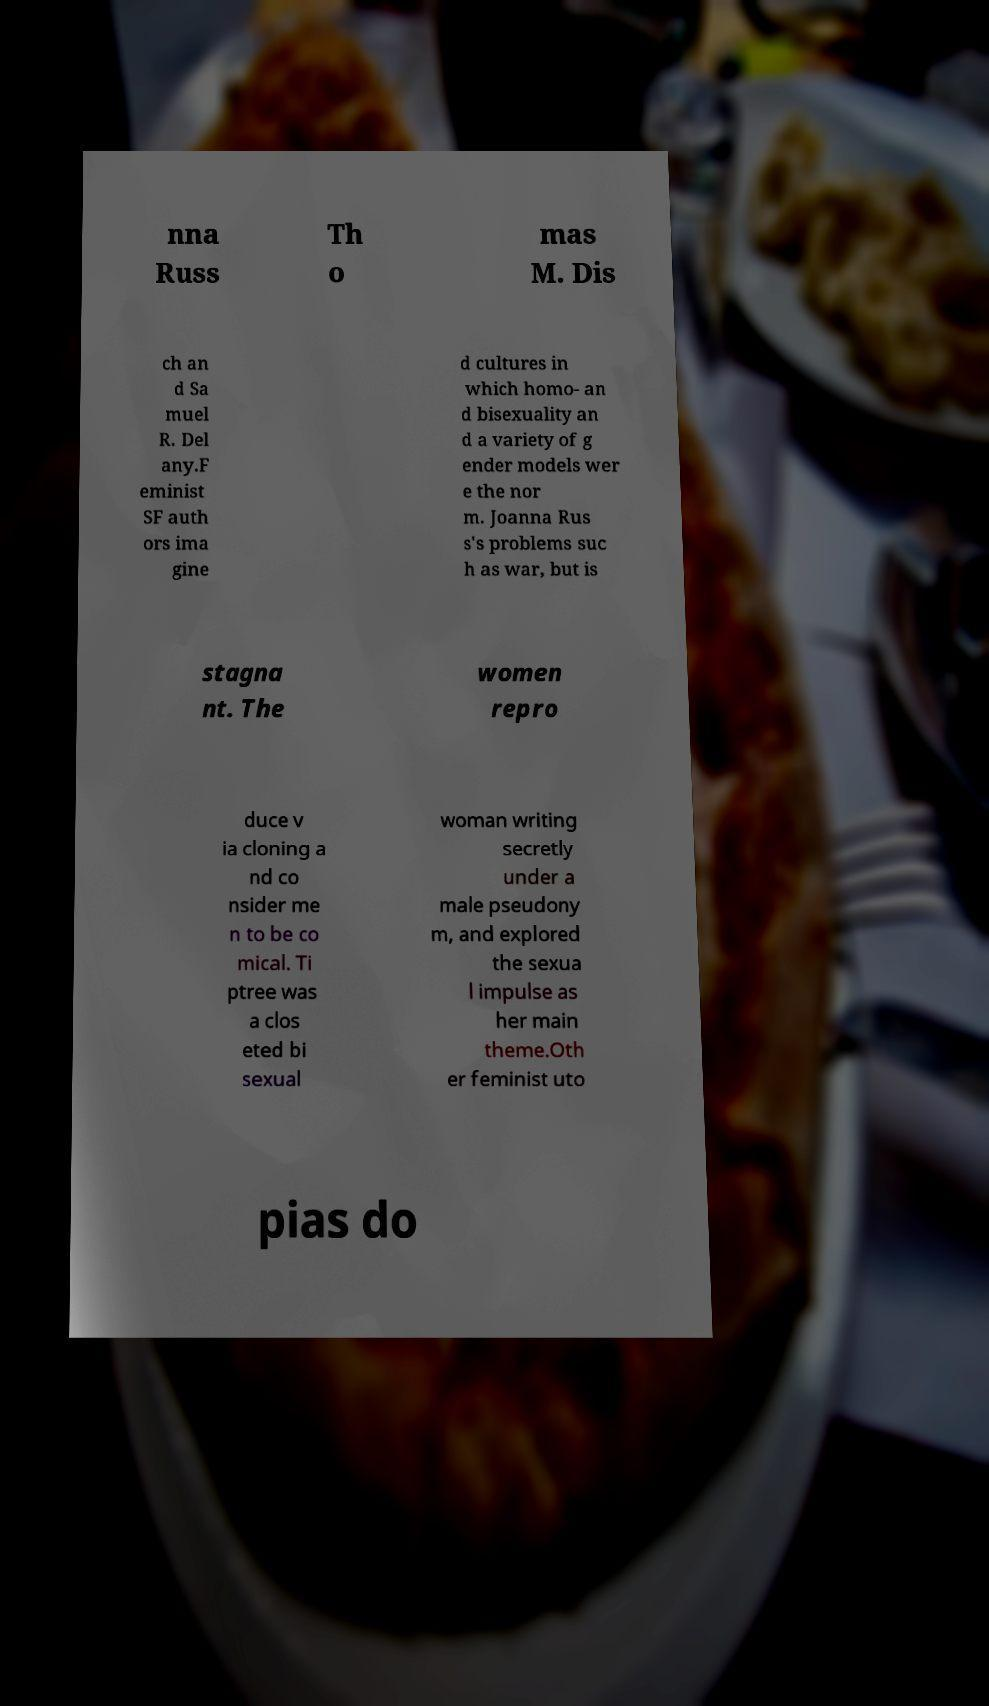Could you extract and type out the text from this image? nna Russ Th o mas M. Dis ch an d Sa muel R. Del any.F eminist SF auth ors ima gine d cultures in which homo- an d bisexuality an d a variety of g ender models wer e the nor m. Joanna Rus s's problems suc h as war, but is stagna nt. The women repro duce v ia cloning a nd co nsider me n to be co mical. Ti ptree was a clos eted bi sexual woman writing secretly under a male pseudony m, and explored the sexua l impulse as her main theme.Oth er feminist uto pias do 